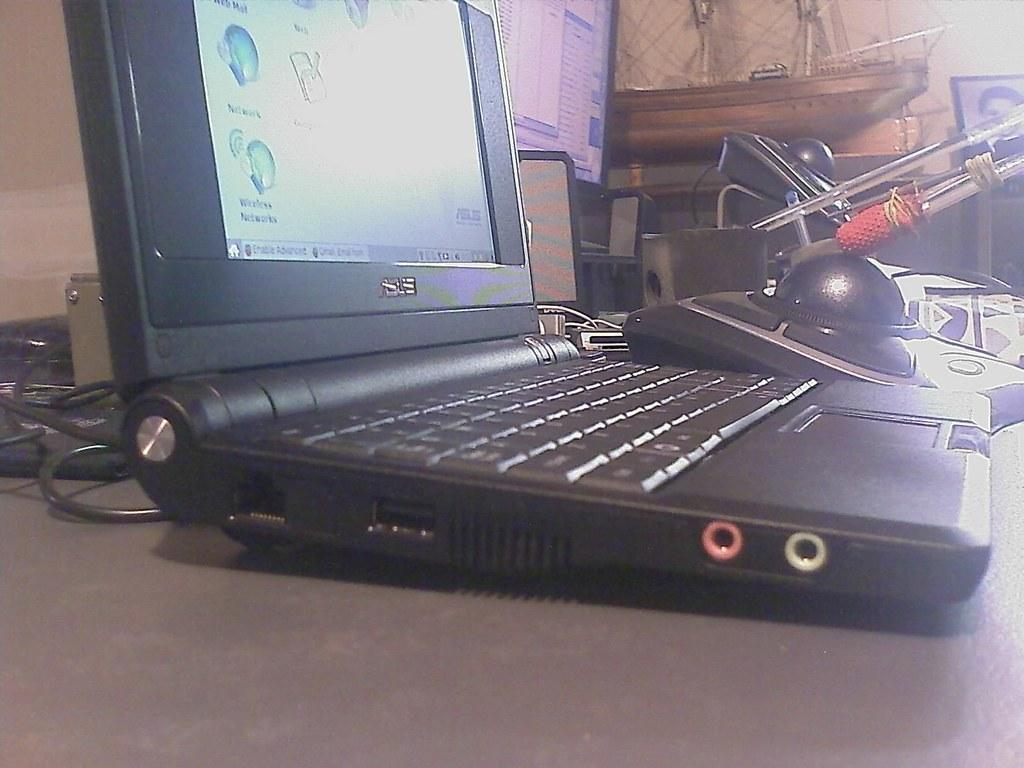What piece of furniture is in the image? There is a table in the image. What electronic device is on the table? There is a laptop on the table. What else can be seen on the table besides the laptop? Cables, a photo frame, and decorations are present on the table. What type of plastic container is visible on the table? There is no plastic container present on the table in the image. 